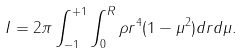<formula> <loc_0><loc_0><loc_500><loc_500>I = 2 \pi \int _ { - 1 } ^ { + 1 } \int _ { 0 } ^ { R } \rho r ^ { 4 } ( 1 - \mu ^ { 2 } ) d r d \mu .</formula> 